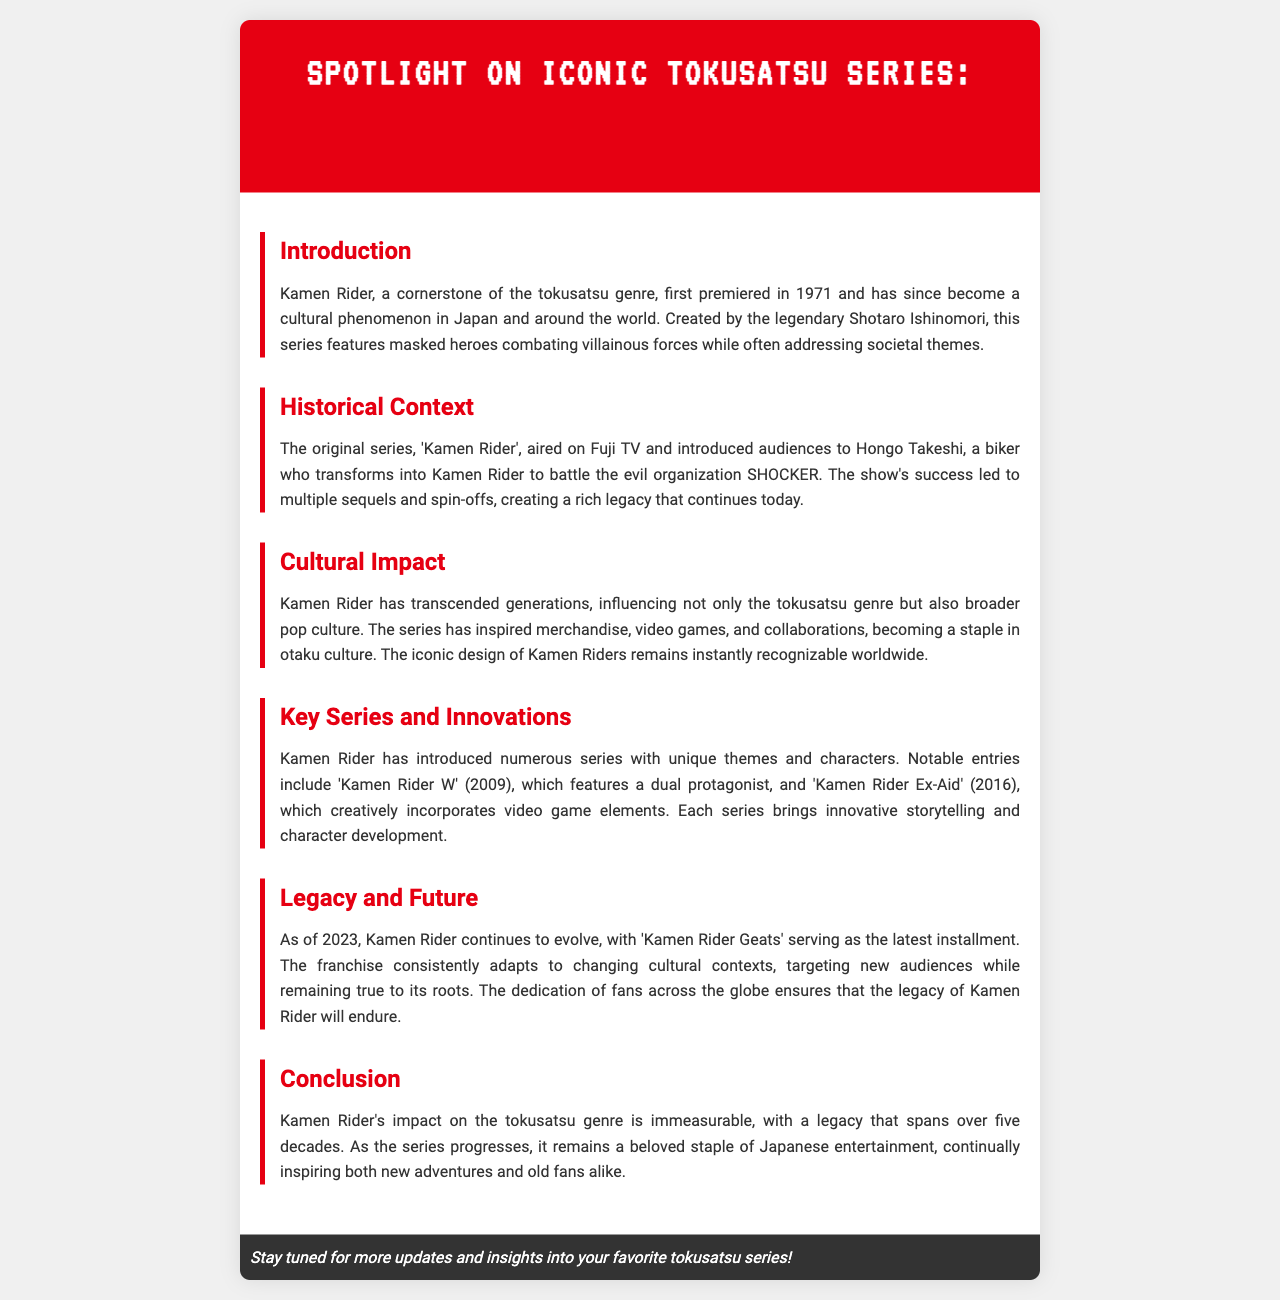What year did Kamen Rider first premiere? The document states that Kamen Rider first premiered in 1971.
Answer: 1971 Who created Kamen Rider? The text indicates that Kamen Rider was created by Shotaro Ishinomori.
Answer: Shotaro Ishinomori What is the name of the evil organization in the original Kamen Rider series? The document mentions that the evil organization is called SHOCKER.
Answer: SHOCKER What series features a dual protagonist? The newsletter highlights 'Kamen Rider W' as the series featuring a dual protagonist.
Answer: Kamen Rider W In what year was Kamen Rider Ex-Aid released? According to the document, Kamen Rider Ex-Aid was released in 2016.
Answer: 2016 Which is the latest installment of Kamen Rider as of 2023? The newsletter identifies 'Kamen Rider Geats' as the latest installment.
Answer: Kamen Rider Geats What genre does Kamen Rider belong to? The document categorizes Kamen Rider under the tokusatsu genre.
Answer: Tokusatsu What significant cultural influence is noted for Kamen Rider? It states that Kamen Rider has influenced merchandise and video games, contributing to its cultural impact.
Answer: Merchandise and video games How many decades has Kamen Rider's legacy spanned? The document mentions that Kamen Rider's legacy spans over five decades.
Answer: Five decades 